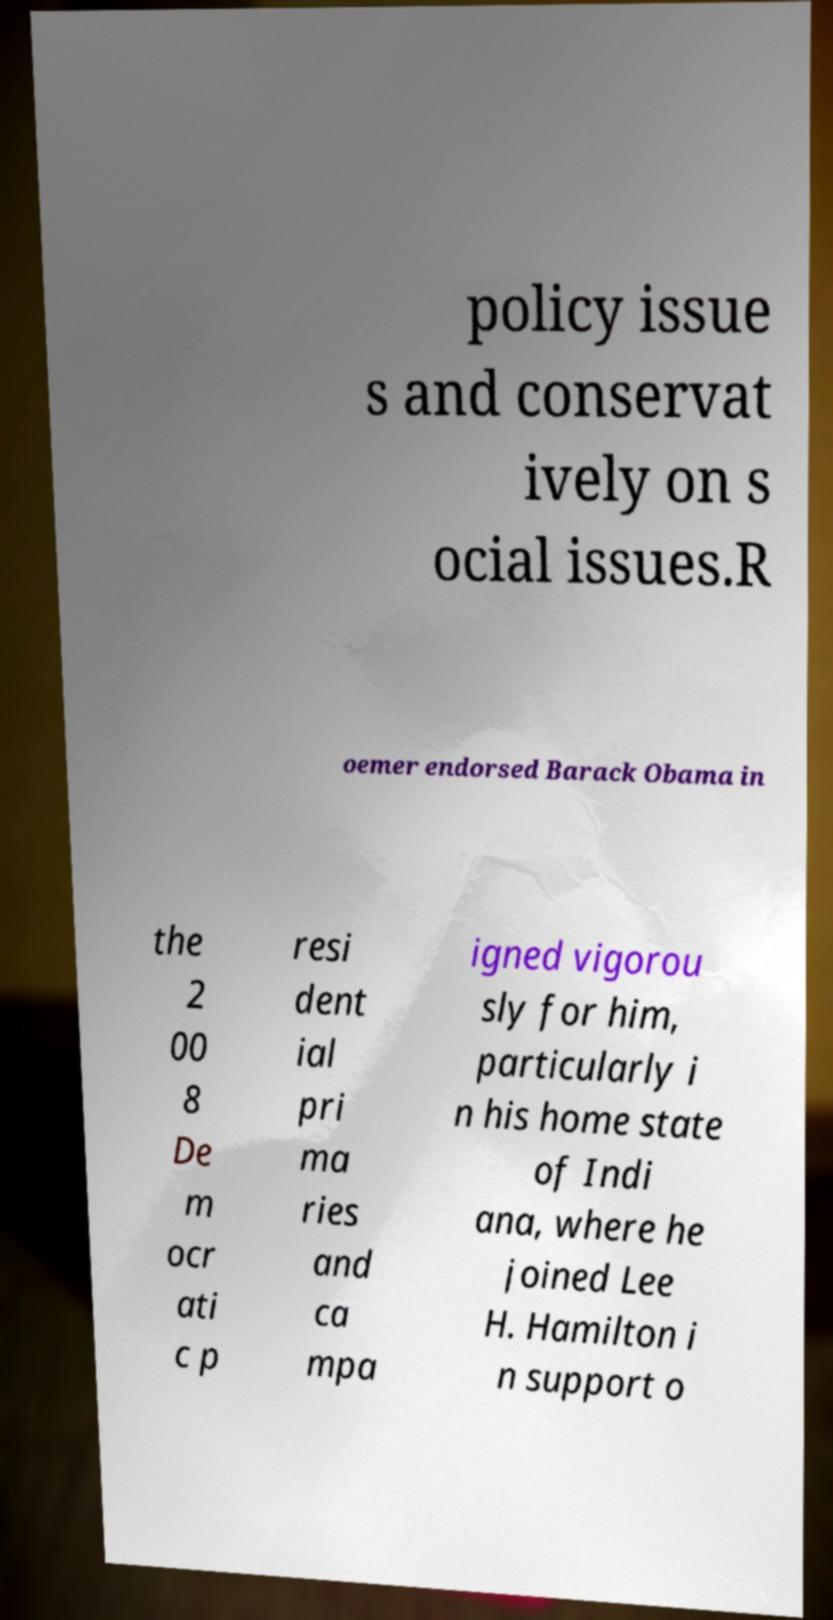Could you assist in decoding the text presented in this image and type it out clearly? policy issue s and conservat ively on s ocial issues.R oemer endorsed Barack Obama in the 2 00 8 De m ocr ati c p resi dent ial pri ma ries and ca mpa igned vigorou sly for him, particularly i n his home state of Indi ana, where he joined Lee H. Hamilton i n support o 